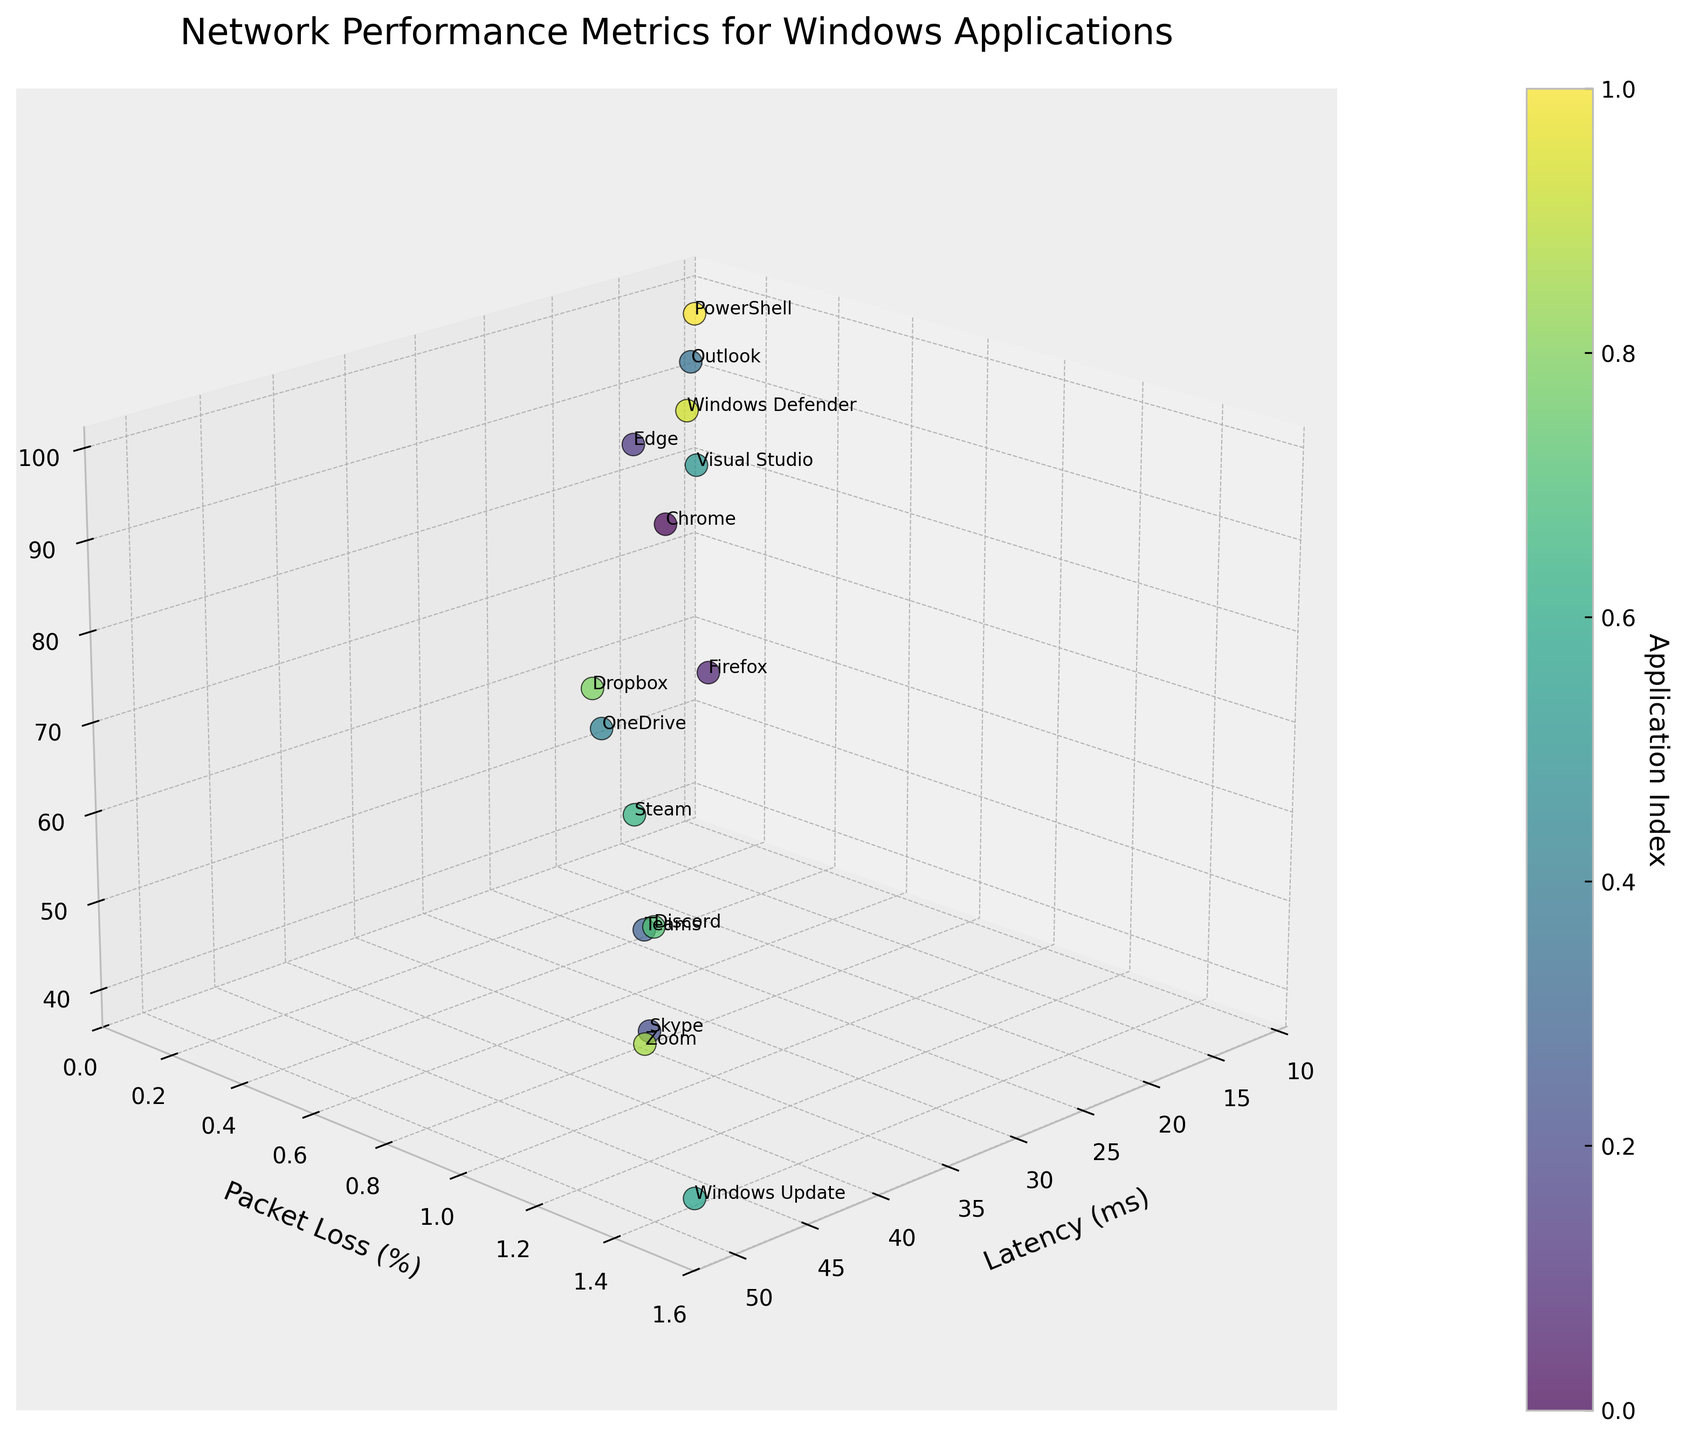Which application has the lowest latency? Look at the 'Latency (ms)' axis and identify the application with the smallest value. PowerShell has the lowest latency at 12 ms.
Answer: PowerShell What is the packet loss percentage for Zoom? Identify the point labeled 'Zoom' and read the value on the 'Packet Loss (%)' axis. Zoom has a packet loss percentage of 1.3%.
Answer: 1.3% Which application shows the highest throughput? Find the point with the highest value on the 'Throughput (Mbps)' axis. PowerShell shows the highest throughput at 98 Mbps.
Answer: PowerShell What is the relationship between latency and throughput for Outlook compared to Edge? Compare the points labeled 'Outlook' and 'Edge' for their 'Latency (ms)' and 'Throughput (Mbps)' values. Outlook has 15 ms latency and 95 Mbps throughput, while Edge has 22 ms latency and 90 Mbps throughput. Outlook has lower latency and higher throughput compared to Edge.
Answer: Outlook has lower latency and higher throughput How many applications have a packet loss percentage higher than 1.0%? Count the number of application points where the 'Packet Loss (%)' value is greater than 1.0%. There are 5 applications with packet loss percentage higher than 1.0%.
Answer: 5 Which application has the highest latency? Look for the point with the highest value on the 'Latency (ms)' axis. Windows Update has the highest latency at 50 ms.
Answer: Windows Update What is the average throughput of applications with a latency below 30 ms? Identify the applications with 'Latency (ms)' below 30 ms and compute the average of their 'Throughput (Mbps)' values. The relevant applications are Outlook (95 Mbps), PowerShell (98 Mbps), Edge (90 Mbps), Visual Studio (88 Mbps), and Chrome (85 Mbps). The average throughput is (95 + 98 + 90 + 88 + 85) / 5 = 91.2 Mbps.
Answer: 91.2 Mbps What is the approximate color code for the Steam application? Steam's position in the dataset dictates its assigned color based on the colormap. As the actual color codes are not specified, visually identify Steam's spot and its corresponding color in the viridis colormap range. The color falls somewhere in the middle range of the colormap.
Answer: Middle range color How does Skype's throughput compare to Discord's? Find the 'Throughput (Mbps)' values for Skype and Discord and compare. Skype has a throughput of 50 Mbps, while Discord has a throughput of 58 Mbps. Discord has higher throughput than Skype.
Answer: Discord has higher throughput Which application shows a higher packet loss percentage, OneDrive or Dropbox? Compare the 'Packet Loss (%)' values for OneDrive and Dropbox. OneDrive has 0.7% packet loss, while Dropbox has 0.6%. OneDrive has a higher packet loss percentage.
Answer: OneDrive 